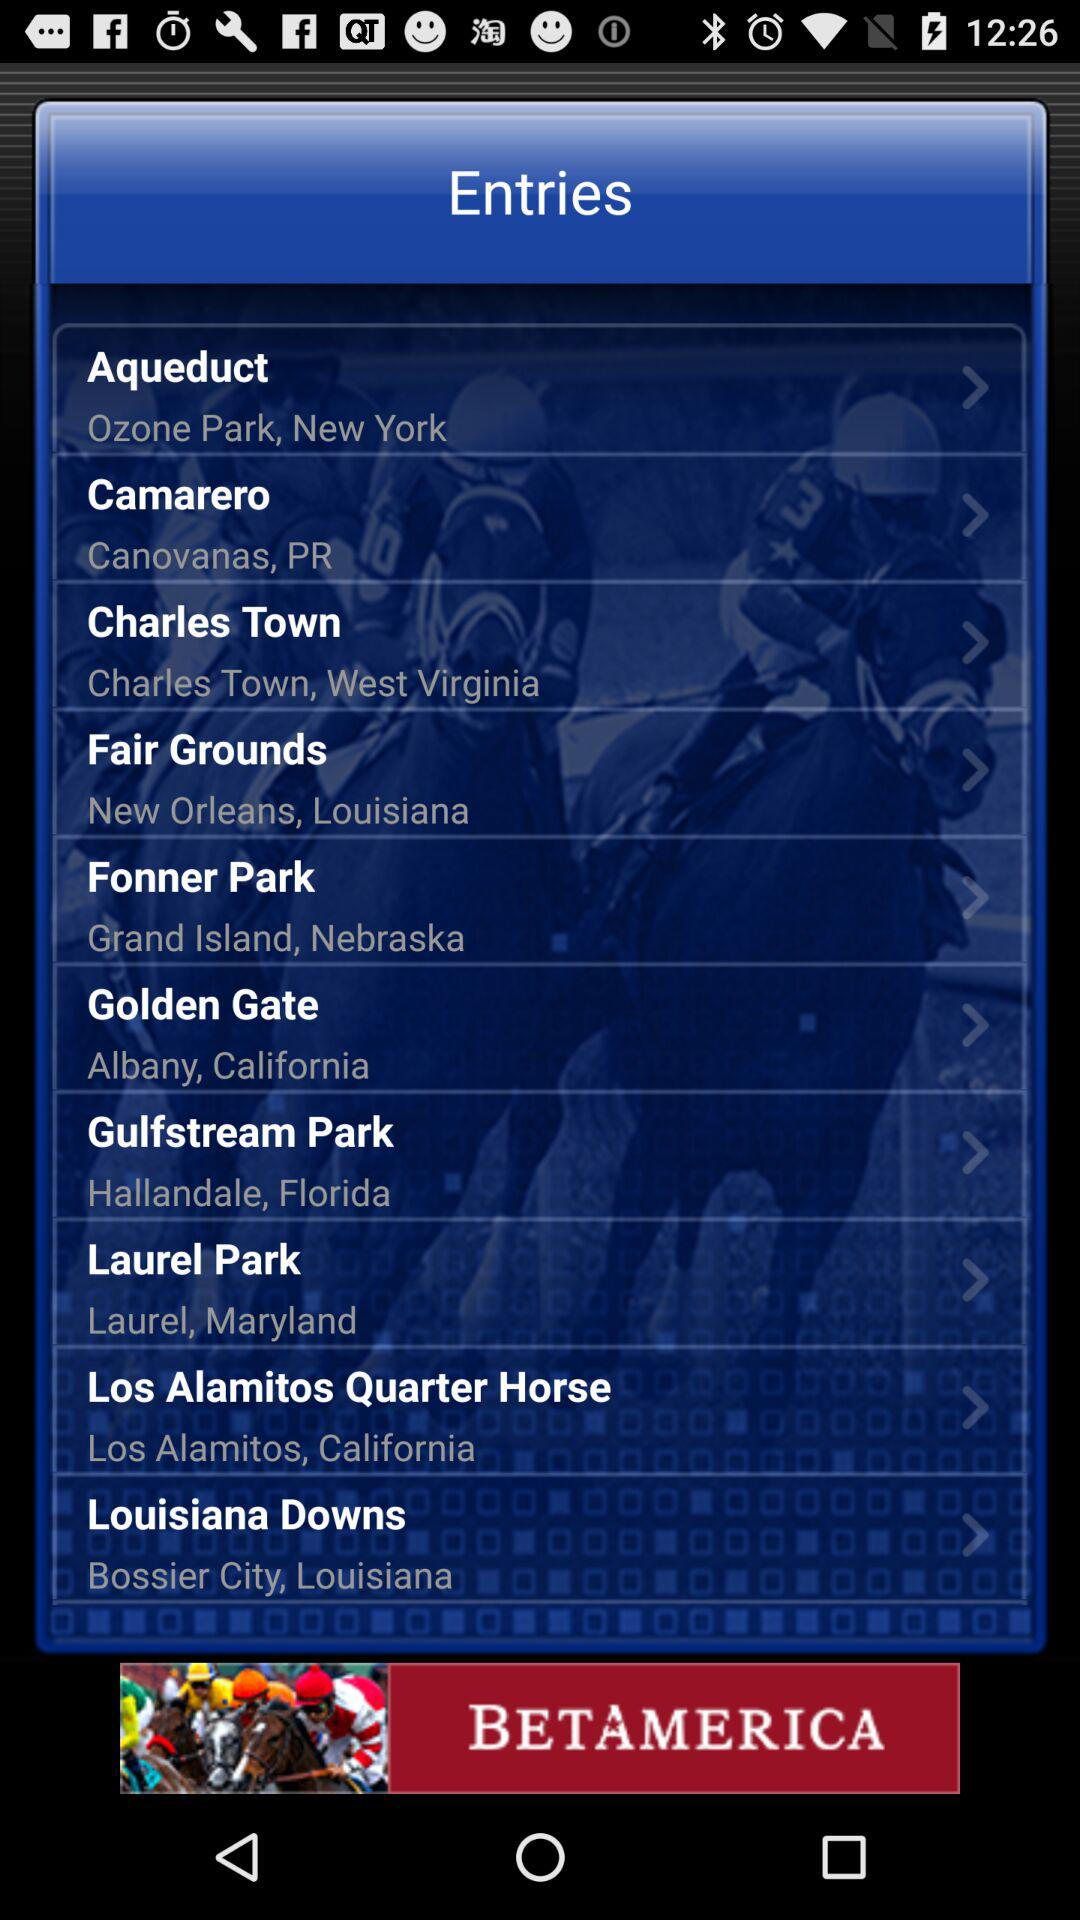What's the location of Laurel Park? Its location is Laurel, Maryland. 